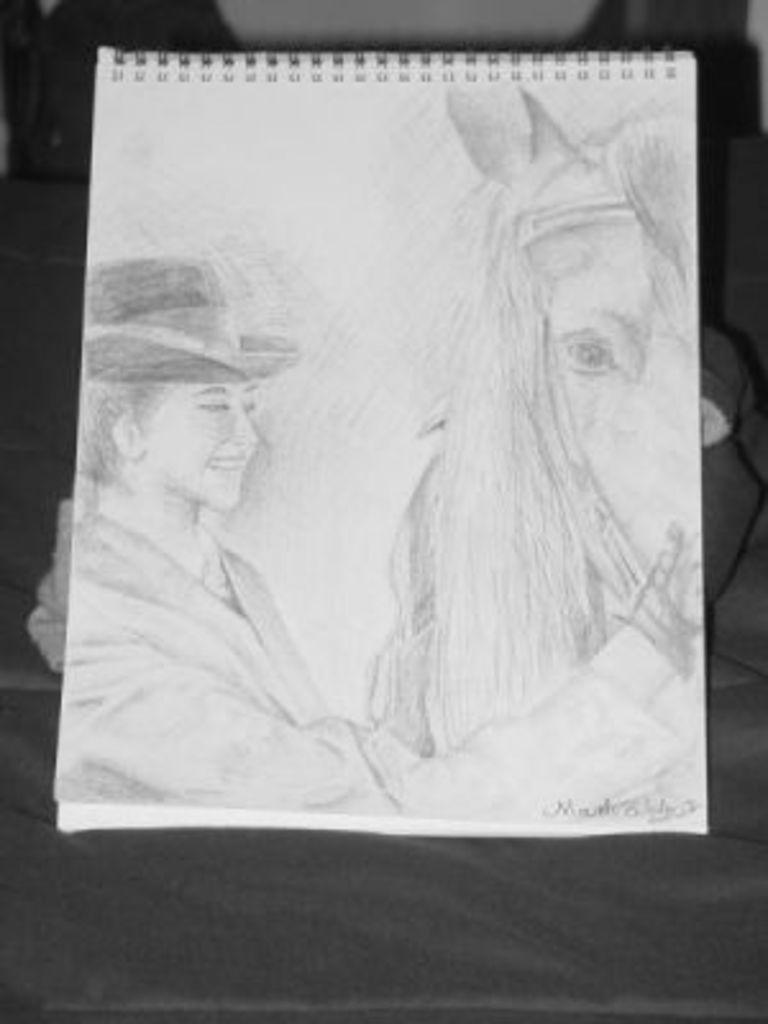What type of drawing is depicted in the image? The image appears to be a sketch. Can you describe the main subject of the sketch? There is a person in the sketch. What is the person doing in the sketch? The person is touching a horse. What is the person wearing in the sketch? The person is wearing a hat. What other animal is present in the sketch? There is a horse in the sketch. What type of cable is being used to control the doll in the image? There is no doll or cable present in the image; it features a person touching a horse. What degree does the person in the image have? The image does not provide information about the person's education or degrees. 